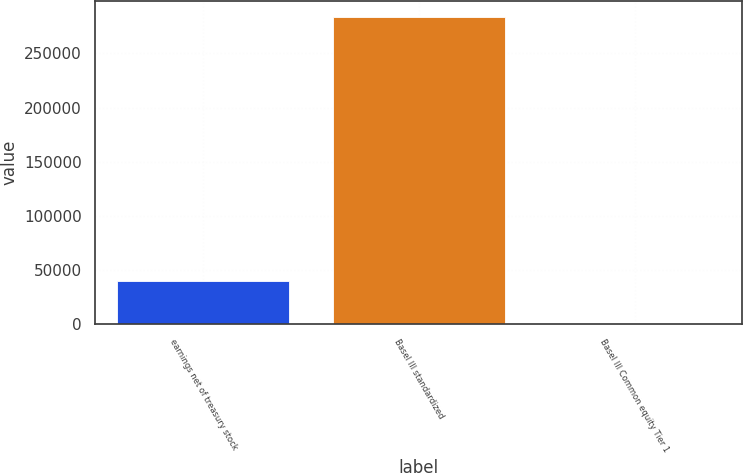Convert chart. <chart><loc_0><loc_0><loc_500><loc_500><bar_chart><fcel>earnings net of treasury stock<fcel>Basel III standardized<fcel>Basel III Common equity Tier 1<nl><fcel>40103<fcel>284018<fcel>10.9<nl></chart> 